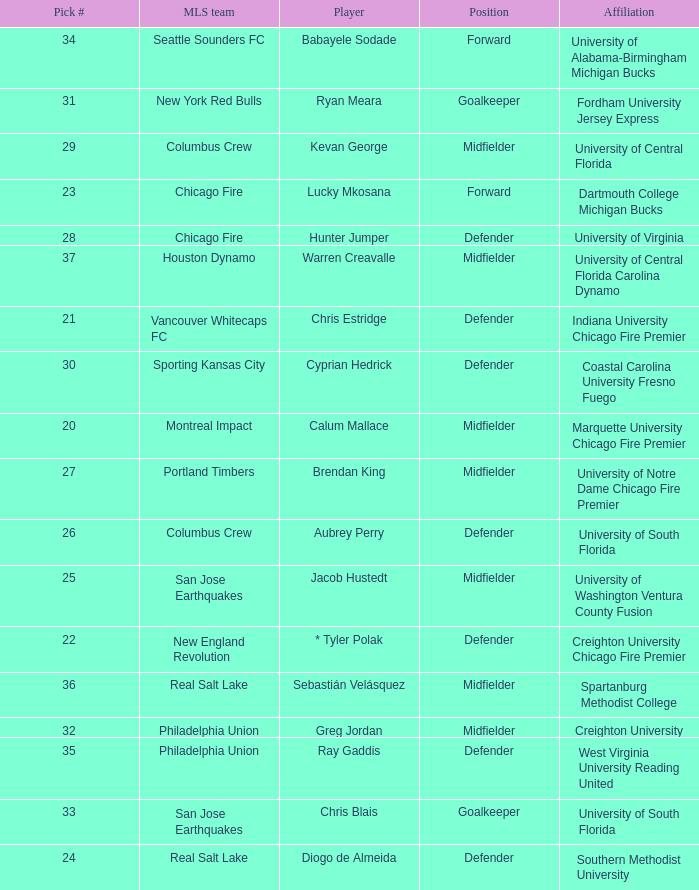Who was pick number 34? Babayele Sodade. 